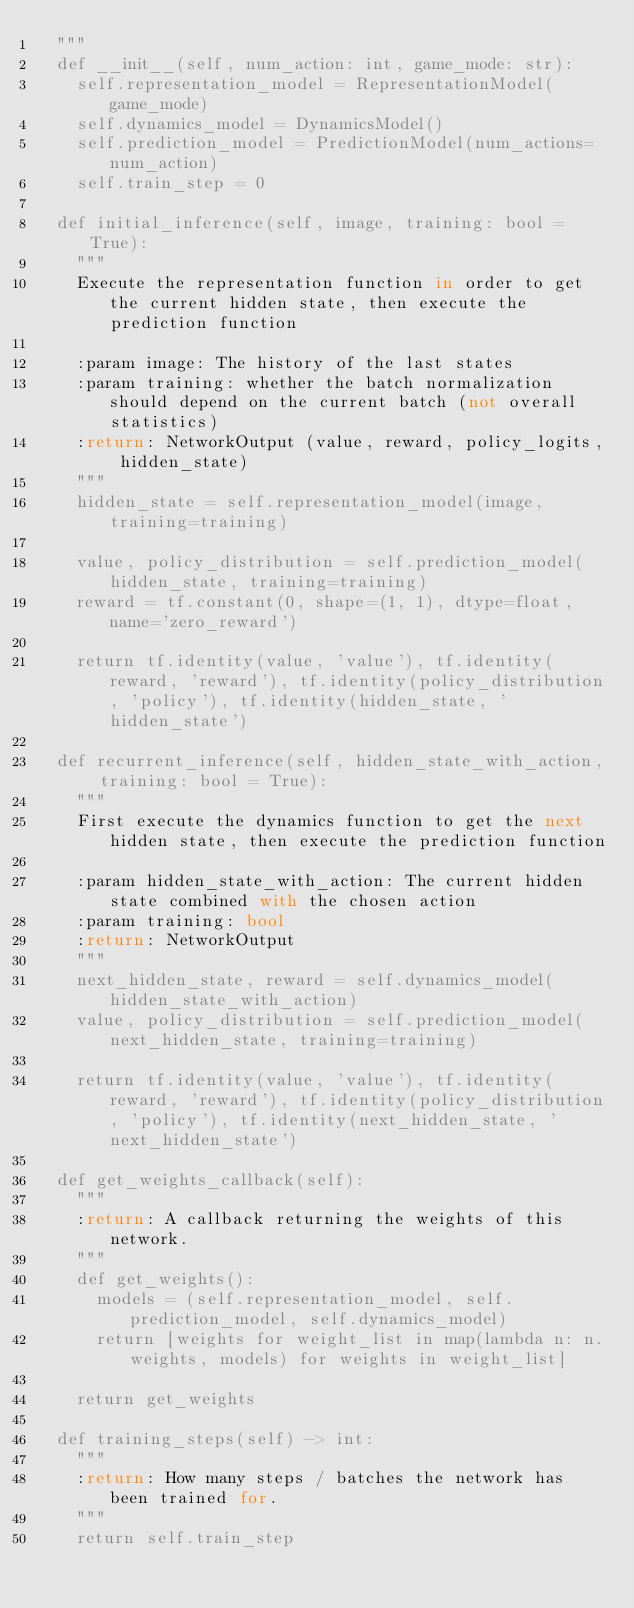Convert code to text. <code><loc_0><loc_0><loc_500><loc_500><_Python_>	"""
	def __init__(self, num_action: int, game_mode: str):
		self.representation_model = RepresentationModel(game_mode)
		self.dynamics_model = DynamicsModel()
		self.prediction_model = PredictionModel(num_actions=num_action)
		self.train_step = 0

	def initial_inference(self, image, training: bool = True):
		"""
		Execute the representation function in order to get the current hidden state, then execute the prediction function

		:param image: The history of the last states
		:param training: whether the batch normalization should depend on the current batch (not overall statistics)
		:return: NetworkOutput (value, reward, policy_logits, hidden_state)
		"""
		hidden_state = self.representation_model(image, training=training)

		value, policy_distribution = self.prediction_model(hidden_state, training=training)
		reward = tf.constant(0, shape=(1, 1), dtype=float, name='zero_reward')

		return tf.identity(value, 'value'), tf.identity(reward, 'reward'), tf.identity(policy_distribution, 'policy'), tf.identity(hidden_state, 'hidden_state')

	def recurrent_inference(self, hidden_state_with_action, training: bool = True):
		"""
		First execute the dynamics function to get the next hidden state, then execute the prediction function

		:param hidden_state_with_action: The current hidden state combined with the chosen action
		:param training: bool
		:return: NetworkOutput
		"""
		next_hidden_state, reward = self.dynamics_model(hidden_state_with_action)
		value, policy_distribution = self.prediction_model(next_hidden_state, training=training)

		return tf.identity(value, 'value'), tf.identity(reward, 'reward'), tf.identity(policy_distribution, 'policy'), tf.identity(next_hidden_state, 'next_hidden_state')

	def get_weights_callback(self):
		"""
		:return: A callback returning the weights of this network.
		"""
		def get_weights():
			models = (self.representation_model, self.prediction_model, self.dynamics_model)
			return [weights for weight_list in map(lambda n: n.weights, models) for weights in weight_list]

		return get_weights

	def training_steps(self) -> int:
		"""
		:return: How many steps / batches the network has been trained for.
		"""
		return self.train_step
</code> 